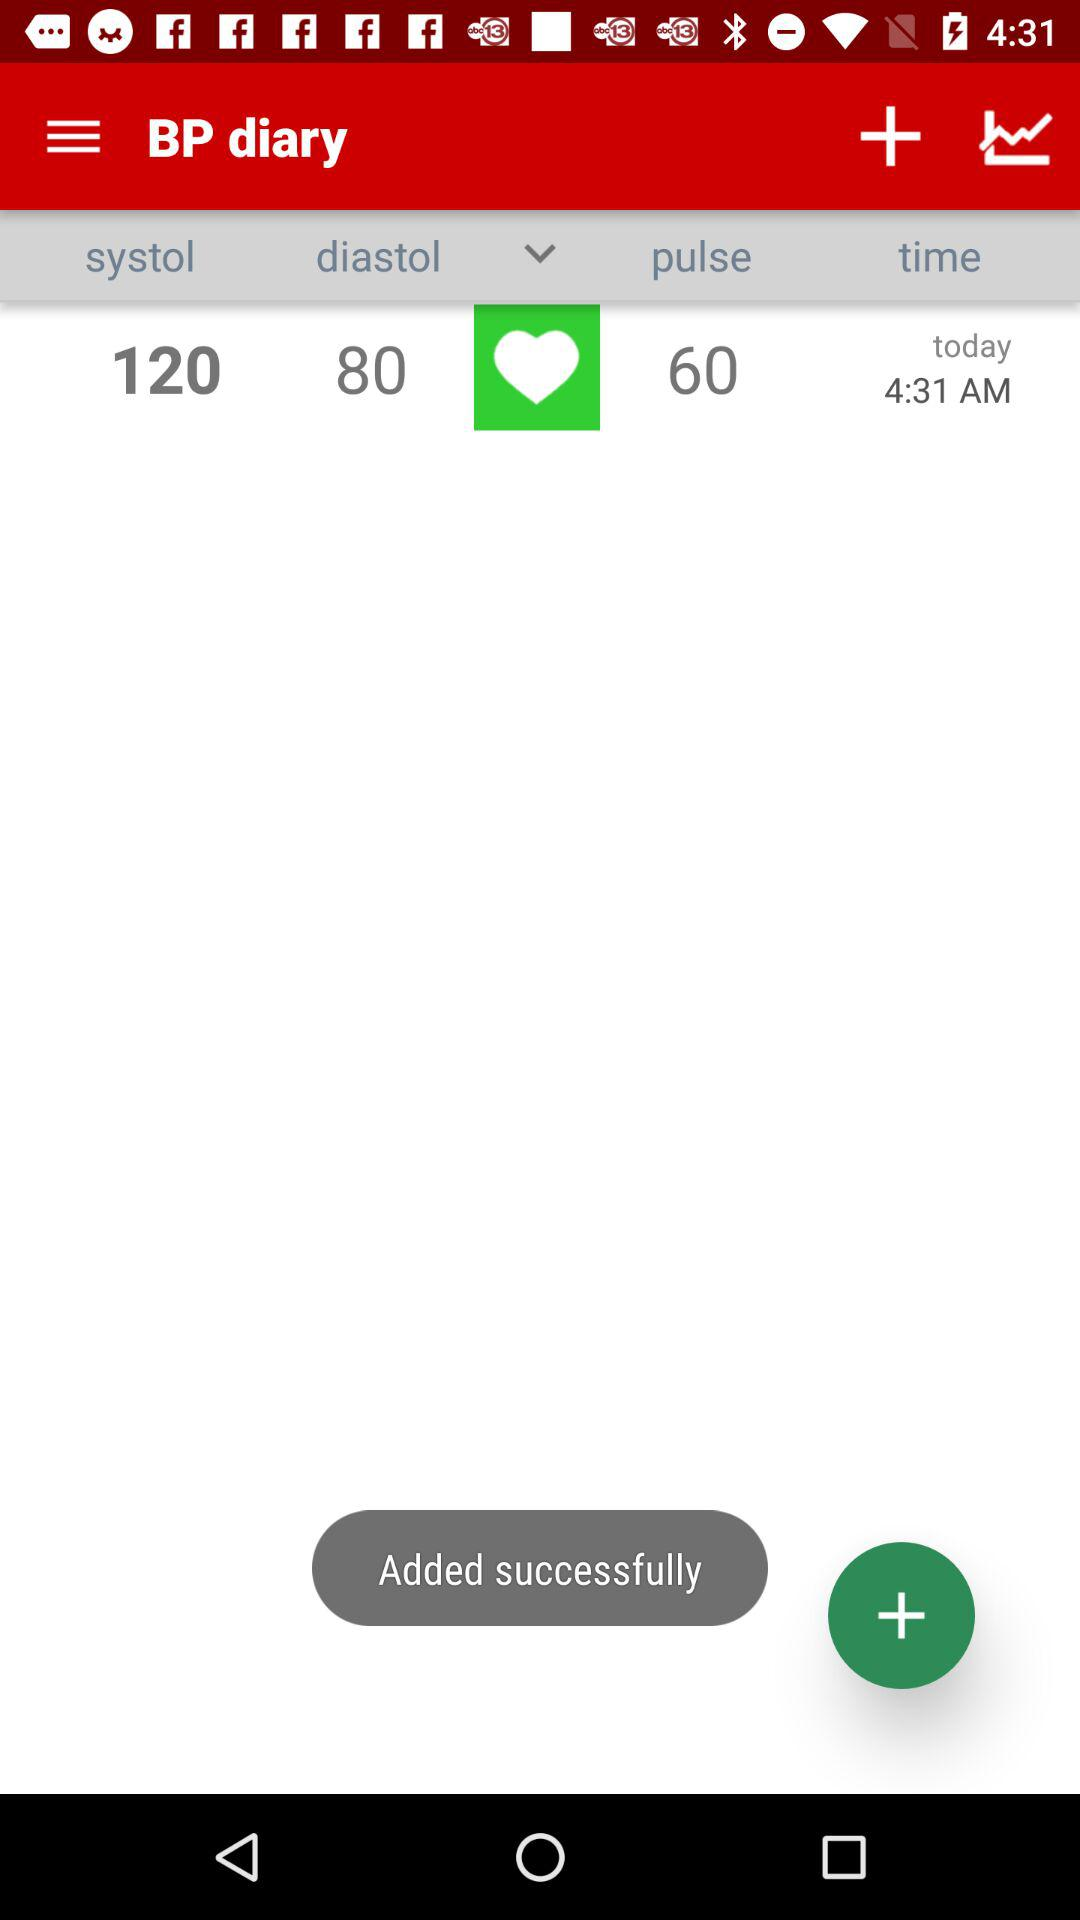What is the pulse rate?
Answer the question using a single word or phrase. 60 